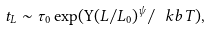<formula> <loc_0><loc_0><loc_500><loc_500>t _ { L } \sim \tau _ { 0 } \exp ( \Upsilon ( L / L _ { 0 } ) ^ { \psi } / \ k b T ) ,</formula> 